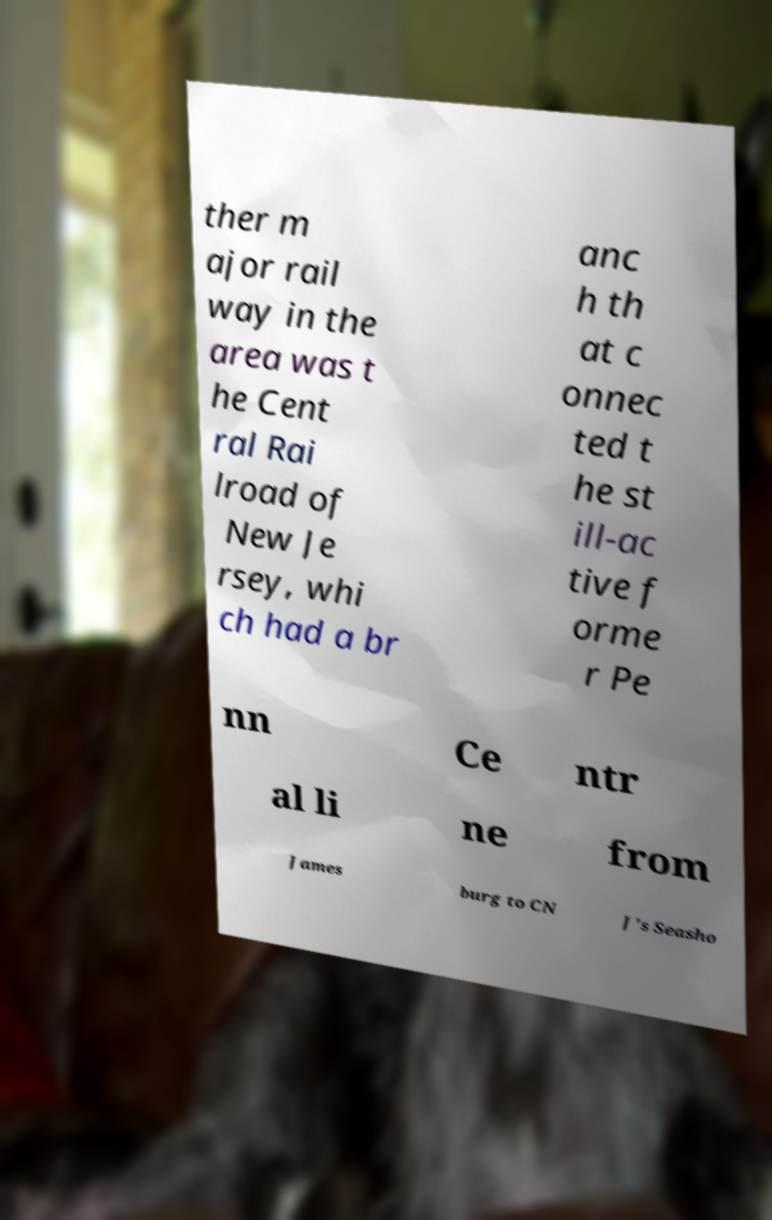Please read and relay the text visible in this image. What does it say? ther m ajor rail way in the area was t he Cent ral Rai lroad of New Je rsey, whi ch had a br anc h th at c onnec ted t he st ill-ac tive f orme r Pe nn Ce ntr al li ne from James burg to CN J's Seasho 